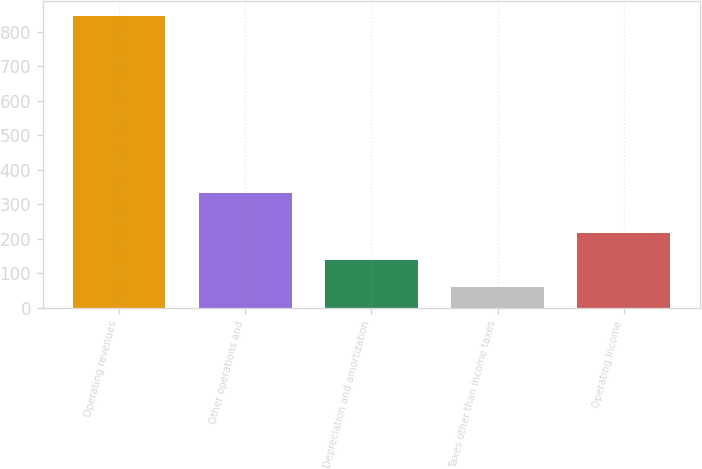<chart> <loc_0><loc_0><loc_500><loc_500><bar_chart><fcel>Operating revenues<fcel>Other operations and<fcel>Depreciation and amortization<fcel>Taxes other than income taxes<fcel>Operating income<nl><fcel>845<fcel>333<fcel>140.3<fcel>62<fcel>218.6<nl></chart> 